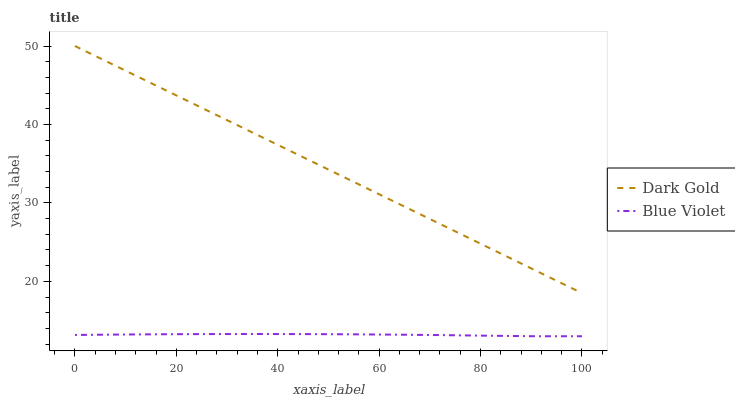Does Blue Violet have the minimum area under the curve?
Answer yes or no. Yes. Does Dark Gold have the maximum area under the curve?
Answer yes or no. Yes. Does Dark Gold have the minimum area under the curve?
Answer yes or no. No. Is Dark Gold the smoothest?
Answer yes or no. Yes. Is Blue Violet the roughest?
Answer yes or no. Yes. Is Dark Gold the roughest?
Answer yes or no. No. Does Dark Gold have the lowest value?
Answer yes or no. No. Does Dark Gold have the highest value?
Answer yes or no. Yes. Is Blue Violet less than Dark Gold?
Answer yes or no. Yes. Is Dark Gold greater than Blue Violet?
Answer yes or no. Yes. Does Blue Violet intersect Dark Gold?
Answer yes or no. No. 